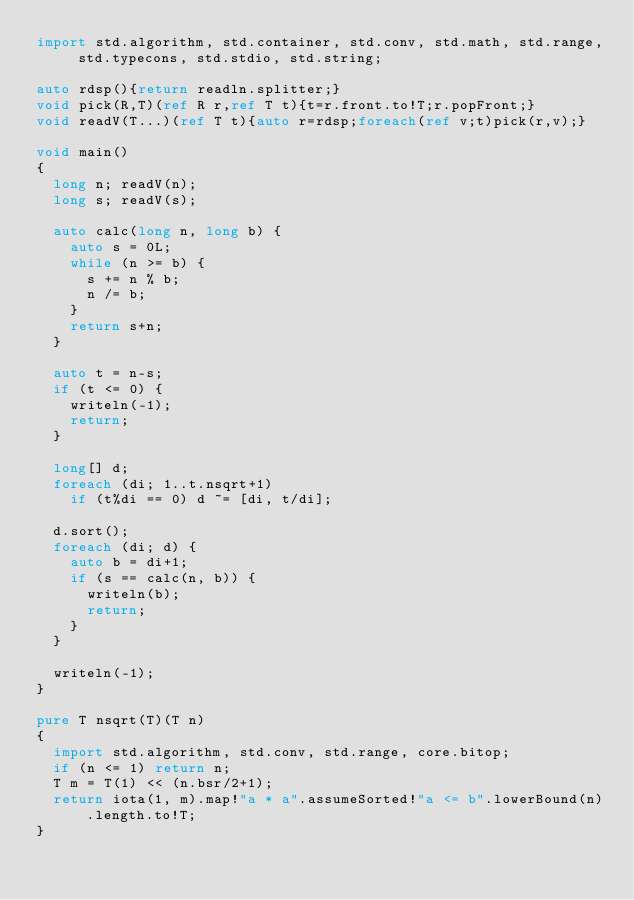<code> <loc_0><loc_0><loc_500><loc_500><_D_>import std.algorithm, std.container, std.conv, std.math, std.range, std.typecons, std.stdio, std.string;

auto rdsp(){return readln.splitter;}
void pick(R,T)(ref R r,ref T t){t=r.front.to!T;r.popFront;}
void readV(T...)(ref T t){auto r=rdsp;foreach(ref v;t)pick(r,v);}

void main()
{
  long n; readV(n);
  long s; readV(s);

  auto calc(long n, long b) {
    auto s = 0L;
    while (n >= b) {
      s += n % b;
      n /= b;
    }
    return s+n;
  }

  auto t = n-s;
  if (t <= 0) {
    writeln(-1);
    return;
  }

  long[] d;
  foreach (di; 1..t.nsqrt+1)
    if (t%di == 0) d ~= [di, t/di];

  d.sort();
  foreach (di; d) {
    auto b = di+1;
    if (s == calc(n, b)) {
      writeln(b);
      return;
    }
  }

  writeln(-1);
}

pure T nsqrt(T)(T n)
{
  import std.algorithm, std.conv, std.range, core.bitop;
  if (n <= 1) return n;
  T m = T(1) << (n.bsr/2+1);
  return iota(1, m).map!"a * a".assumeSorted!"a <= b".lowerBound(n).length.to!T;
}
</code> 